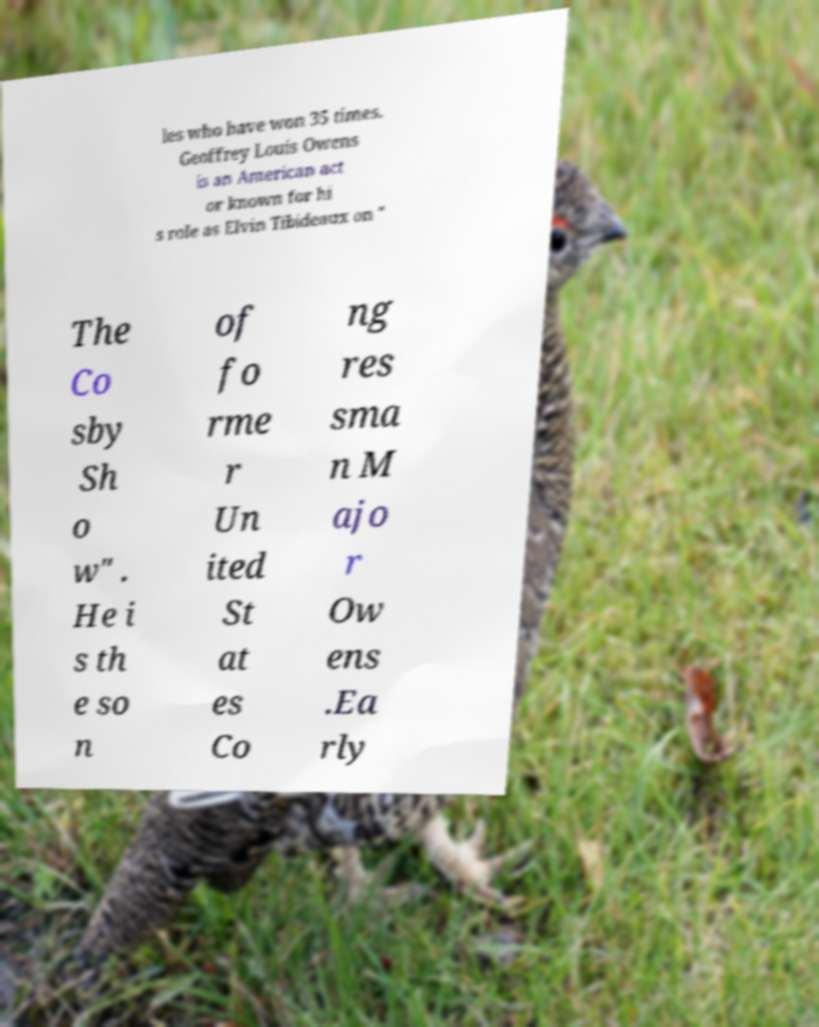Please read and relay the text visible in this image. What does it say? les who have won 35 times. Geoffrey Louis Owens is an American act or known for hi s role as Elvin Tibideaux on " The Co sby Sh o w" . He i s th e so n of fo rme r Un ited St at es Co ng res sma n M ajo r Ow ens .Ea rly 